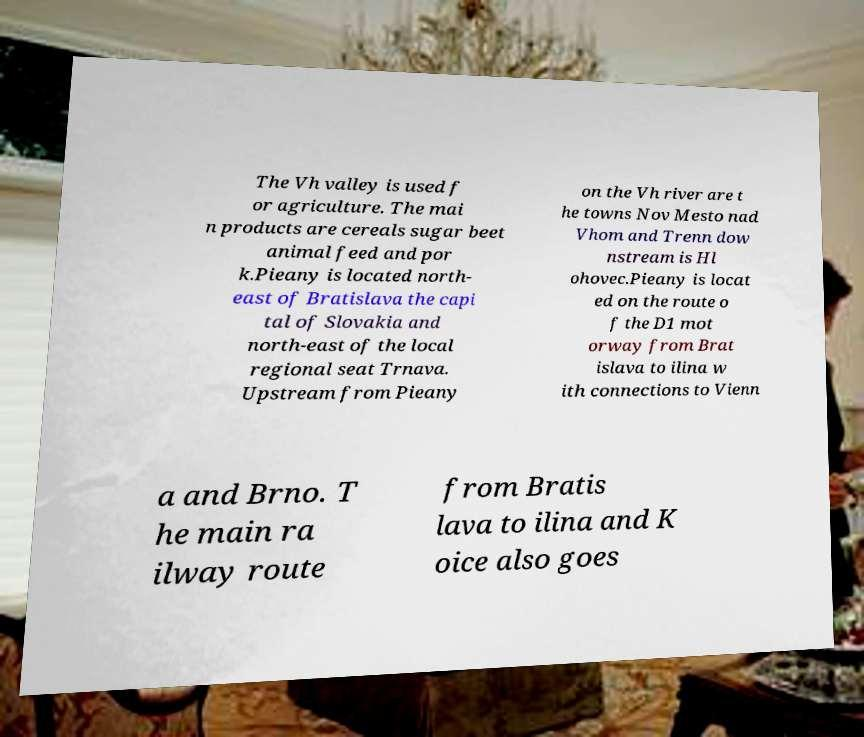Can you read and provide the text displayed in the image?This photo seems to have some interesting text. Can you extract and type it out for me? The Vh valley is used f or agriculture. The mai n products are cereals sugar beet animal feed and por k.Pieany is located north- east of Bratislava the capi tal of Slovakia and north-east of the local regional seat Trnava. Upstream from Pieany on the Vh river are t he towns Nov Mesto nad Vhom and Trenn dow nstream is Hl ohovec.Pieany is locat ed on the route o f the D1 mot orway from Brat islava to ilina w ith connections to Vienn a and Brno. T he main ra ilway route from Bratis lava to ilina and K oice also goes 